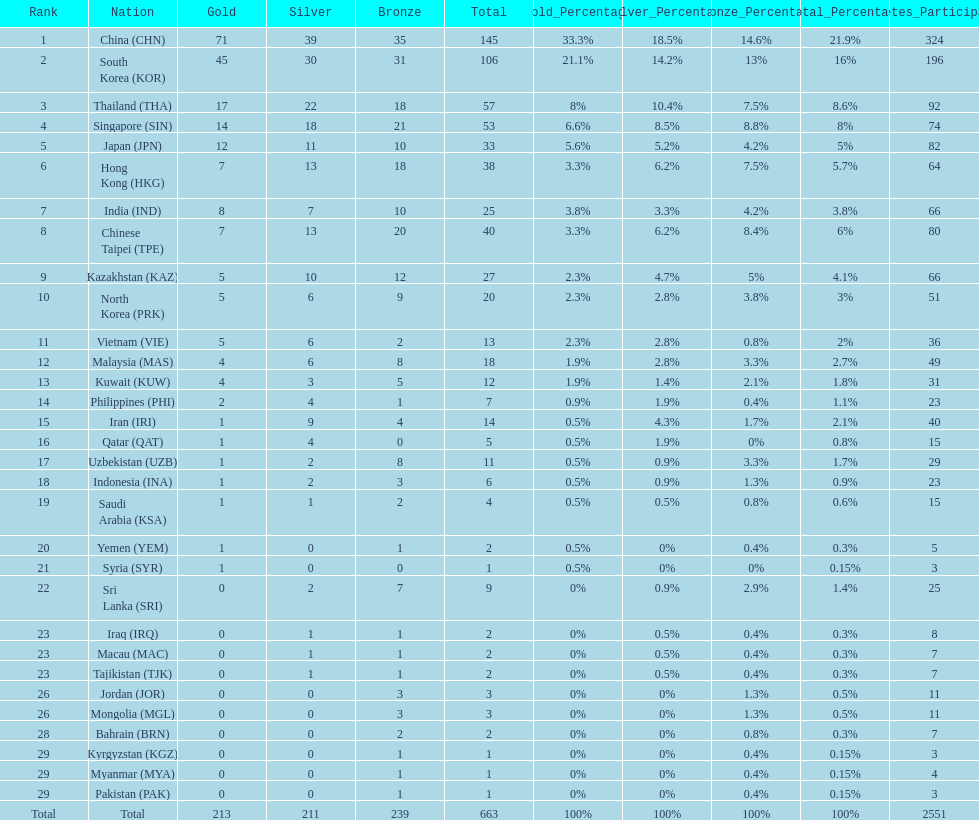How many nations earned at least ten bronze medals? 9. 